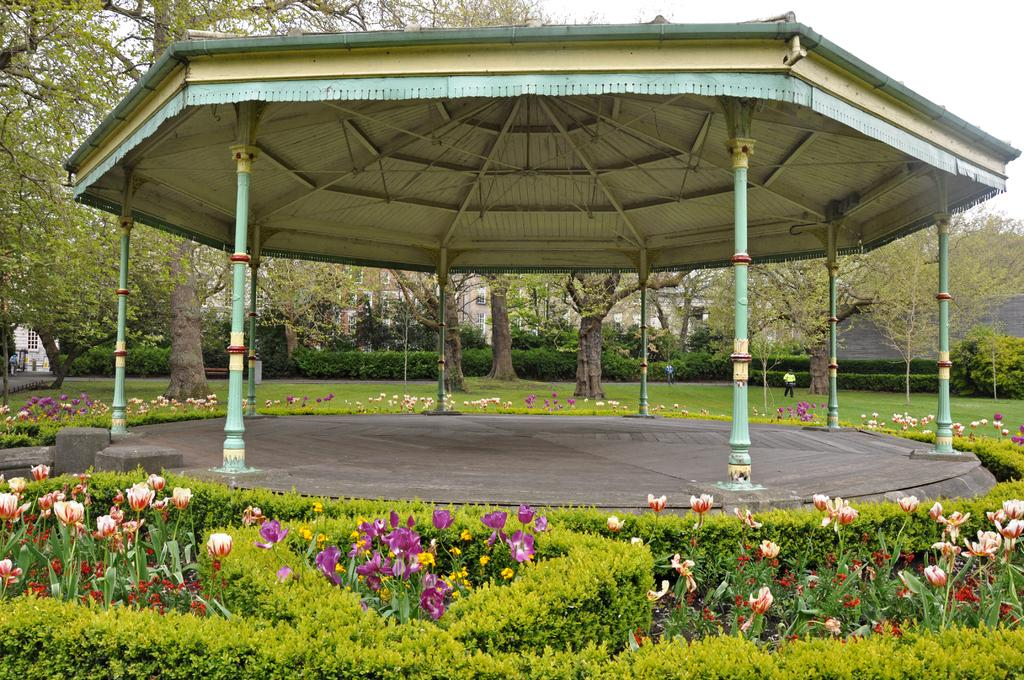What type of plants are at the bottom of the image? There are plants with flowers at the bottom of the image. What structure can be seen in the image? There is a gazebo in the image. What can be seen in the background of the image? There are trees, grass, buildings, and the sky visible in the background of the image. How many persons are in the image? There are two persons on the left side of the image. What type of straw is being used by the persons in the image? There is no straw visible in the image. What discovery was made by the persons in the image? There is no indication of a discovery being made in the image. 